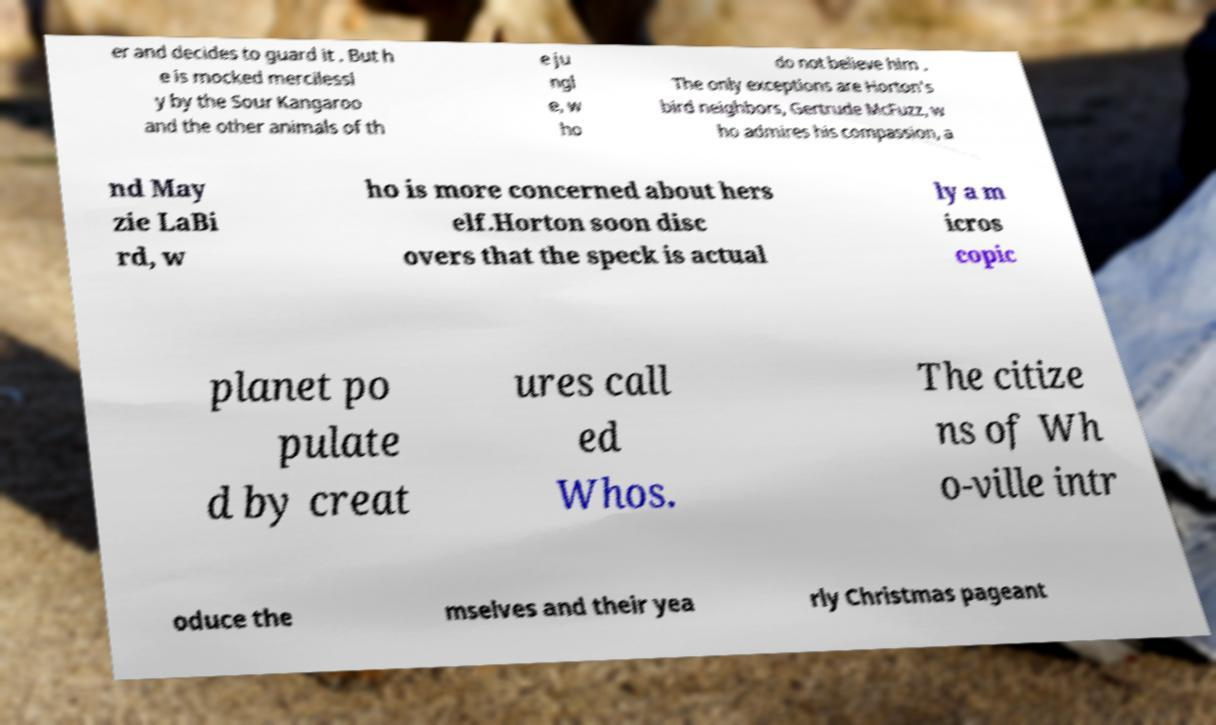What messages or text are displayed in this image? I need them in a readable, typed format. er and decides to guard it . But h e is mocked mercilessl y by the Sour Kangaroo and the other animals of th e ju ngl e, w ho do not believe him . The only exceptions are Horton's bird neighbors, Gertrude McFuzz, w ho admires his compassion, a nd May zie LaBi rd, w ho is more concerned about hers elf.Horton soon disc overs that the speck is actual ly a m icros copic planet po pulate d by creat ures call ed Whos. The citize ns of Wh o-ville intr oduce the mselves and their yea rly Christmas pageant 